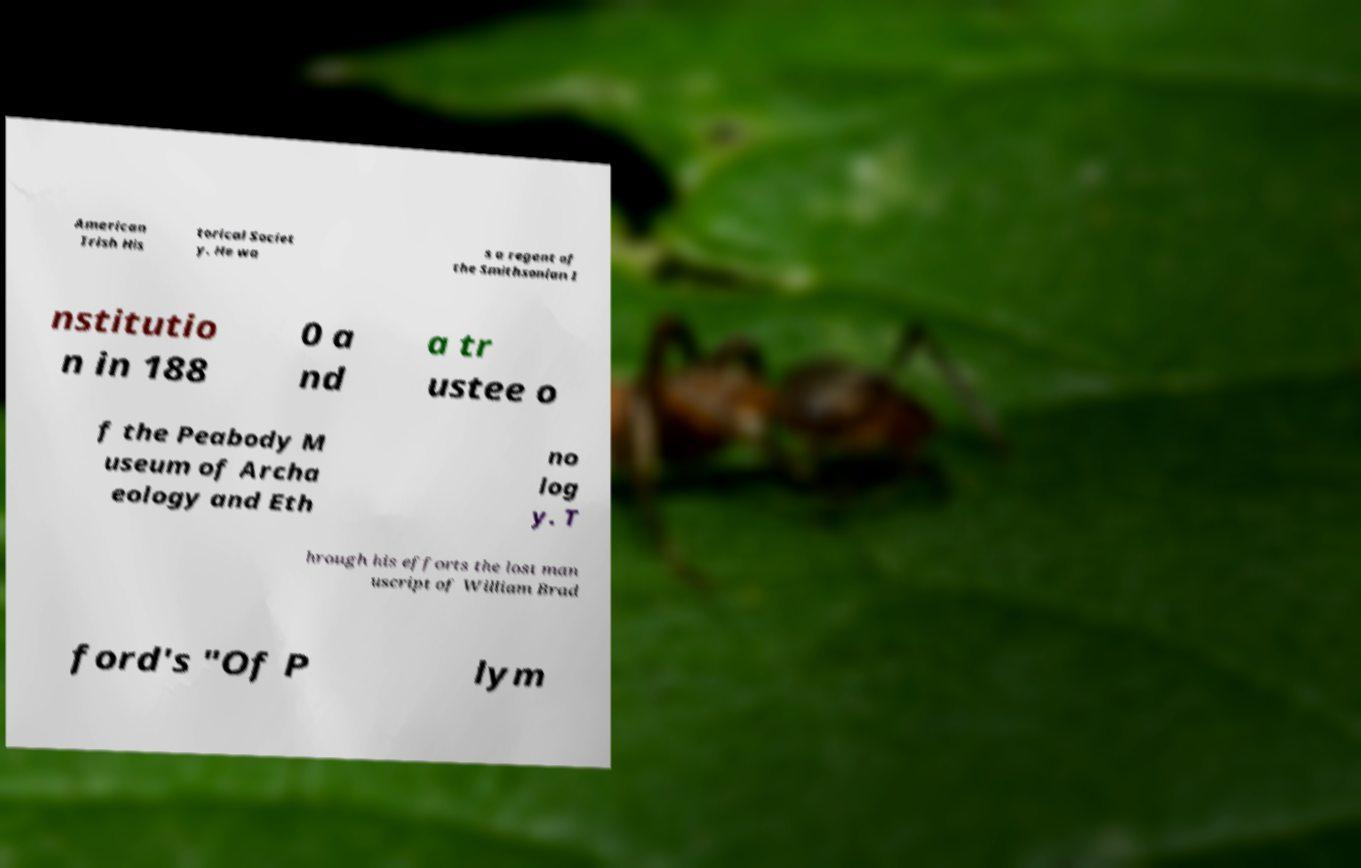Could you assist in decoding the text presented in this image and type it out clearly? American Irish His torical Societ y. He wa s a regent of the Smithsonian I nstitutio n in 188 0 a nd a tr ustee o f the Peabody M useum of Archa eology and Eth no log y. T hrough his efforts the lost man uscript of William Brad ford's "Of P lym 